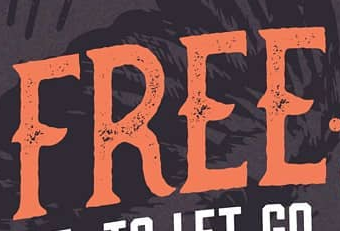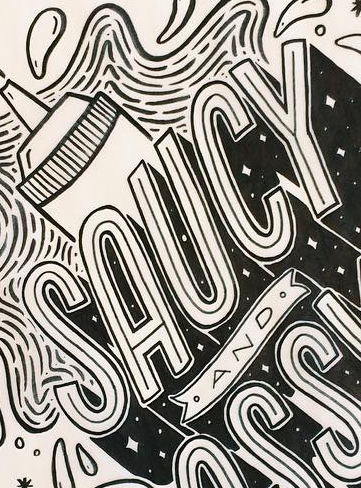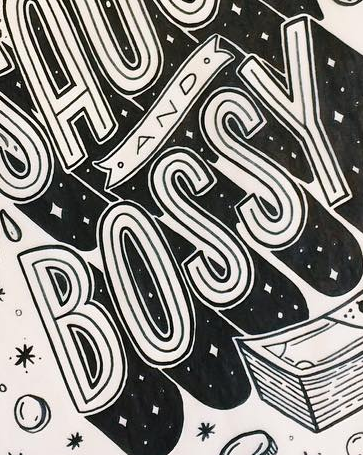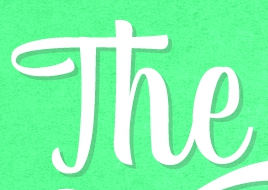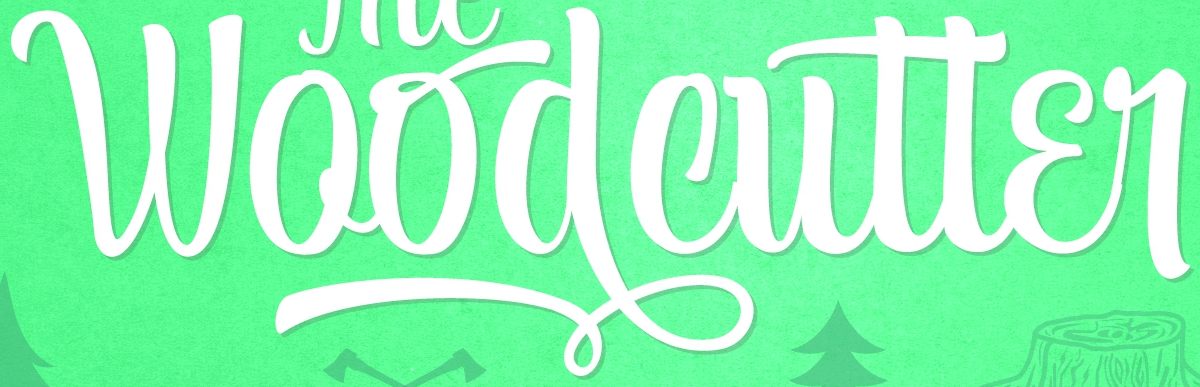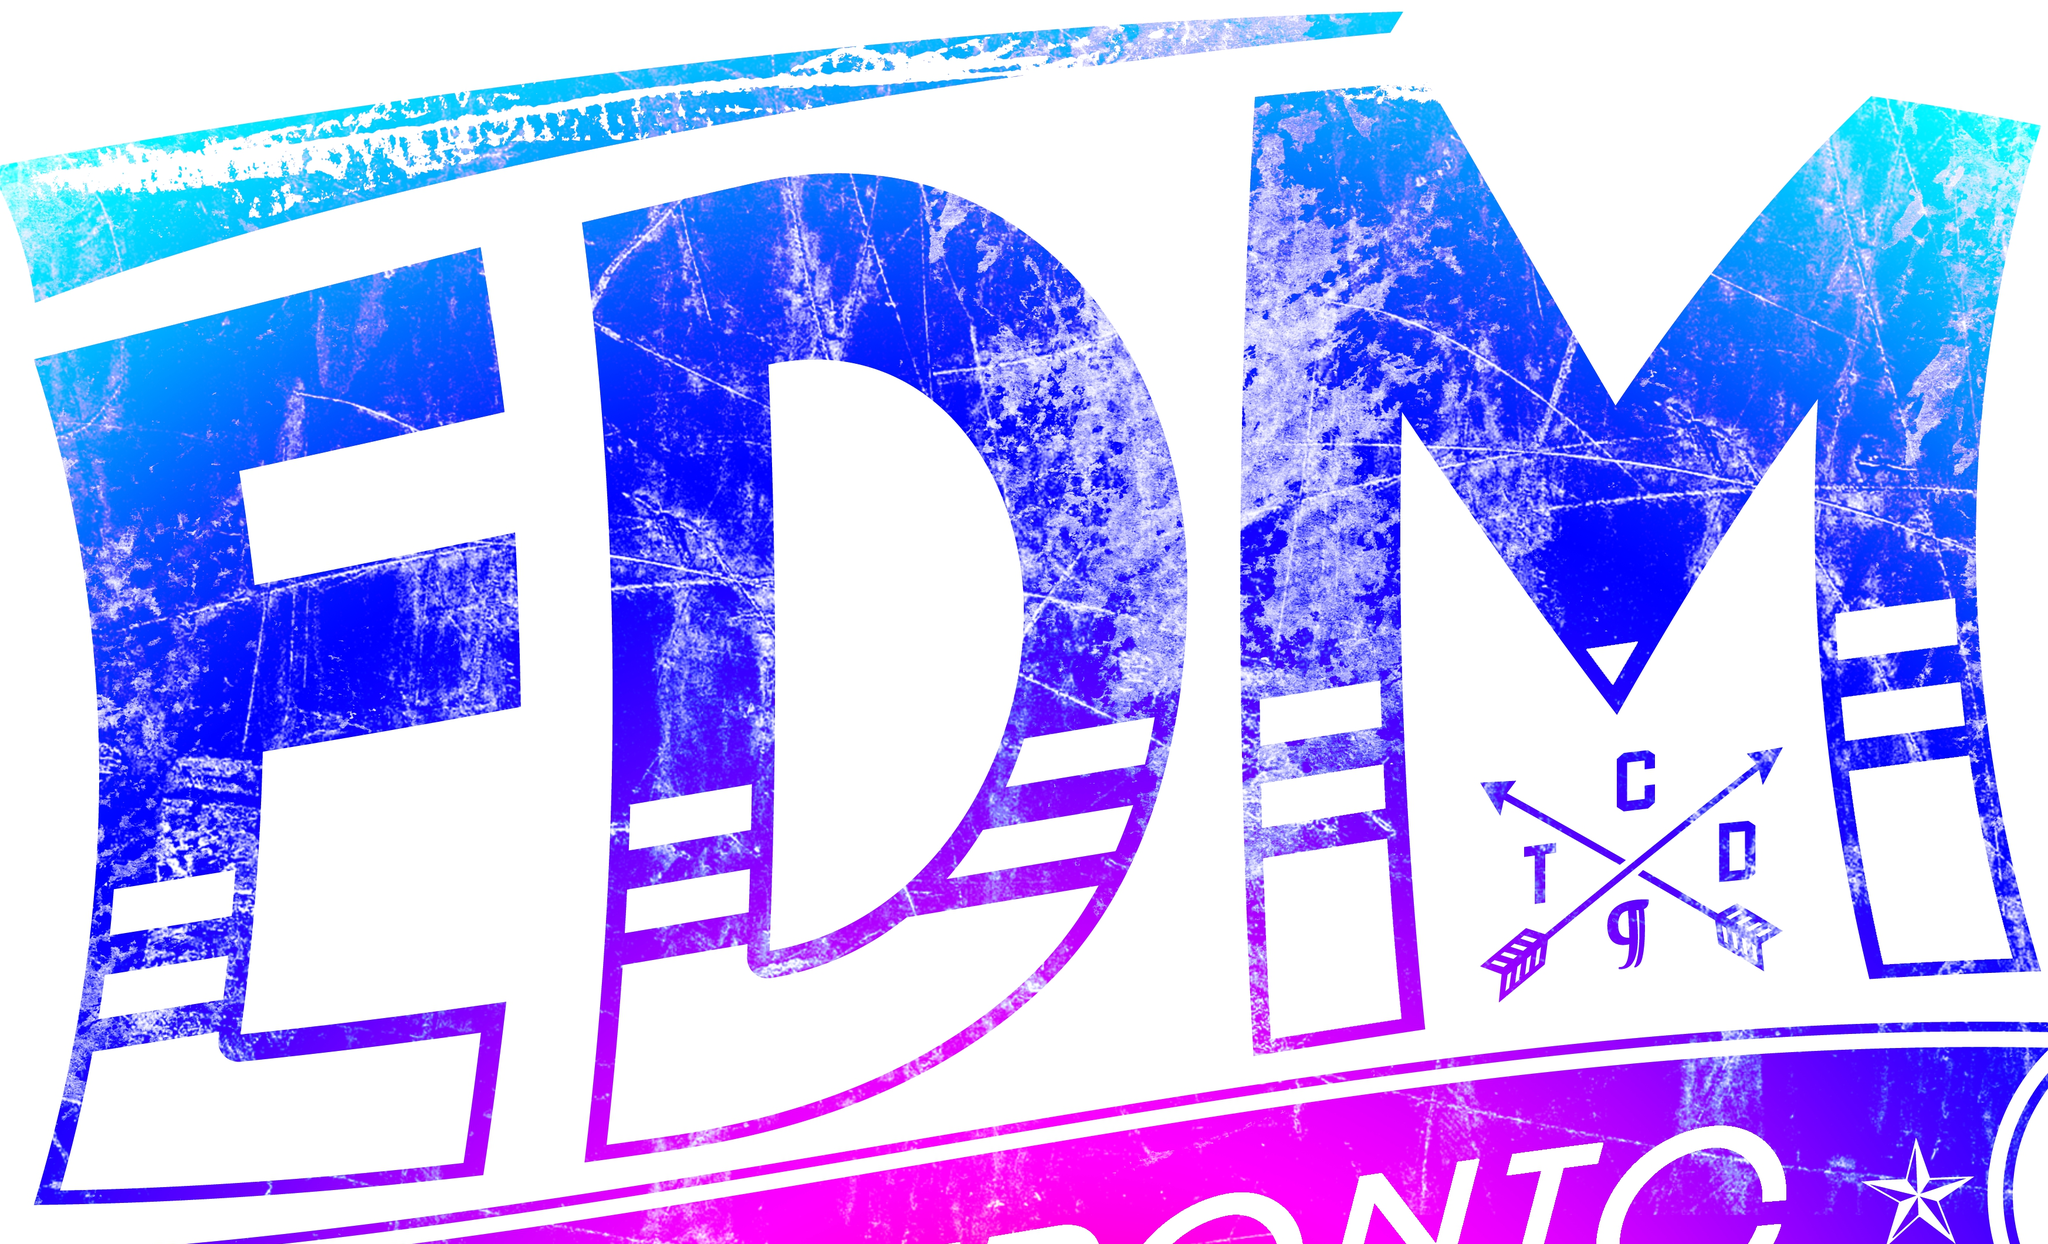Read the text content from these images in order, separated by a semicolon. FREE; SAUCY; BOSSY; The; Woodcutter; EDM 